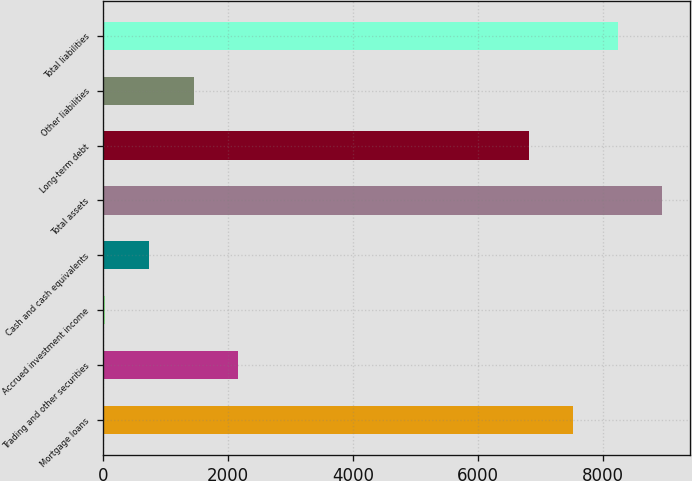Convert chart. <chart><loc_0><loc_0><loc_500><loc_500><bar_chart><fcel>Mortgage loans<fcel>Trading and other securities<fcel>Accrued investment income<fcel>Cash and cash equivalents<fcel>Total assets<fcel>Long-term debt<fcel>Other liabilities<fcel>Total liabilities<nl><fcel>7528<fcel>2158<fcel>34<fcel>742<fcel>8944<fcel>6820<fcel>1450<fcel>8236<nl></chart> 